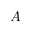Convert formula to latex. <formula><loc_0><loc_0><loc_500><loc_500>A</formula> 